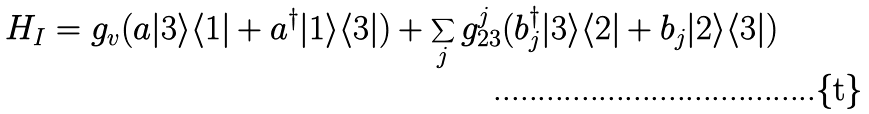<formula> <loc_0><loc_0><loc_500><loc_500>H _ { I } = g _ { v } ( a | 3 \rangle \langle 1 | + a ^ { \dag } | 1 \rangle \langle 3 | ) + \sum _ { j } g ^ { j } _ { 2 3 } ( b _ { j } ^ { \dag } | 3 \rangle \langle 2 | + b _ { j } | 2 \rangle \langle 3 | )</formula> 